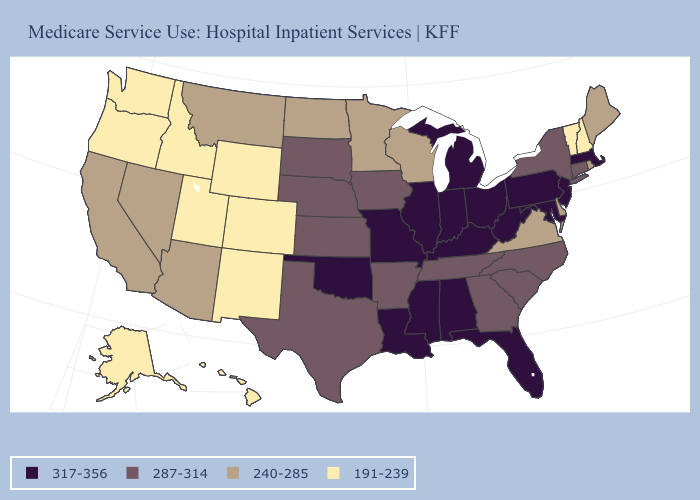Among the states that border Nevada , which have the highest value?
Concise answer only. Arizona, California. What is the value of Kentucky?
Quick response, please. 317-356. Name the states that have a value in the range 240-285?
Answer briefly. Arizona, California, Delaware, Maine, Minnesota, Montana, Nevada, North Dakota, Rhode Island, Virginia, Wisconsin. Is the legend a continuous bar?
Concise answer only. No. Is the legend a continuous bar?
Give a very brief answer. No. Which states have the lowest value in the MidWest?
Quick response, please. Minnesota, North Dakota, Wisconsin. Name the states that have a value in the range 317-356?
Keep it brief. Alabama, Florida, Illinois, Indiana, Kentucky, Louisiana, Maryland, Massachusetts, Michigan, Mississippi, Missouri, New Jersey, Ohio, Oklahoma, Pennsylvania, West Virginia. What is the value of North Dakota?
Answer briefly. 240-285. Does Maryland have the highest value in the USA?
Short answer required. Yes. What is the value of Massachusetts?
Give a very brief answer. 317-356. Among the states that border West Virginia , which have the lowest value?
Keep it brief. Virginia. Which states have the lowest value in the Northeast?
Short answer required. New Hampshire, Vermont. What is the lowest value in the USA?
Write a very short answer. 191-239. Name the states that have a value in the range 287-314?
Answer briefly. Arkansas, Connecticut, Georgia, Iowa, Kansas, Nebraska, New York, North Carolina, South Carolina, South Dakota, Tennessee, Texas. Which states hav the highest value in the South?
Give a very brief answer. Alabama, Florida, Kentucky, Louisiana, Maryland, Mississippi, Oklahoma, West Virginia. 